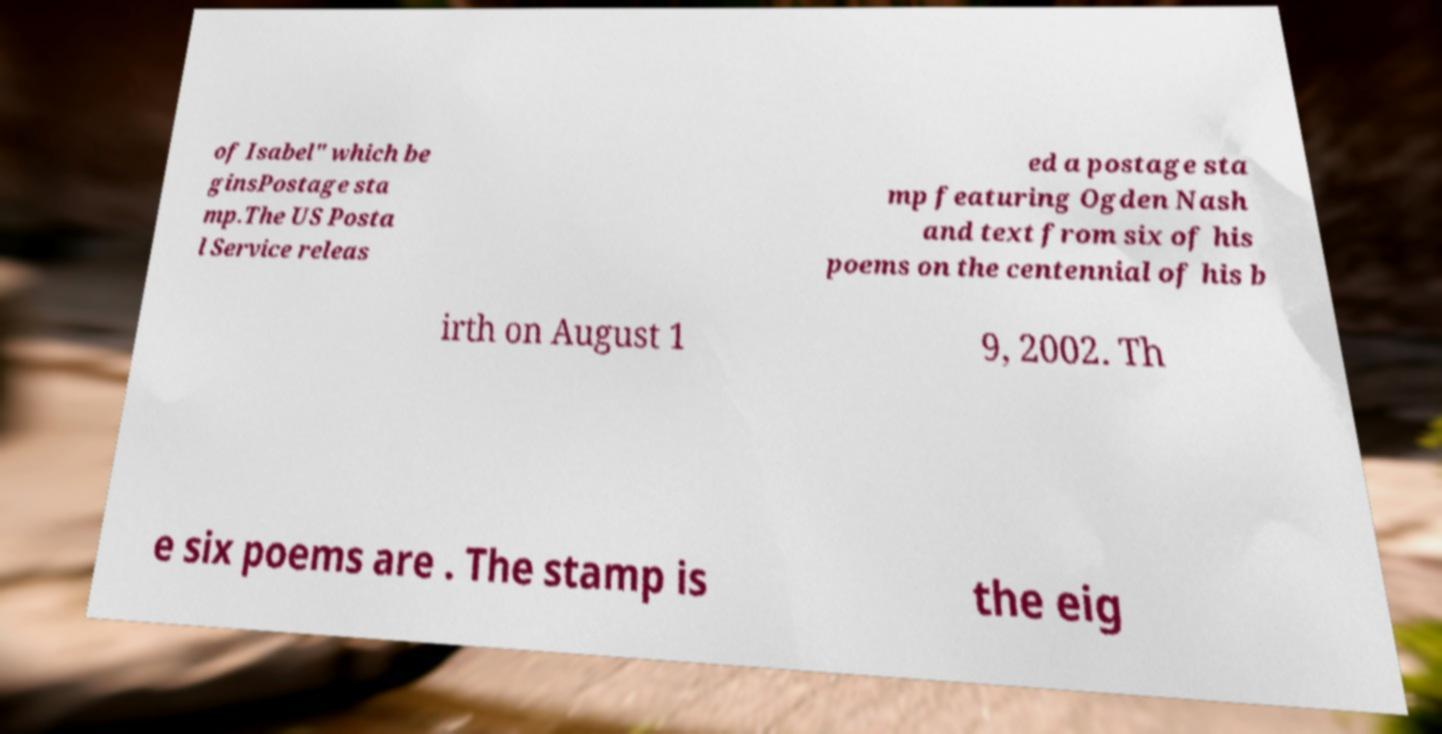Please read and relay the text visible in this image. What does it say? of Isabel" which be ginsPostage sta mp.The US Posta l Service releas ed a postage sta mp featuring Ogden Nash and text from six of his poems on the centennial of his b irth on August 1 9, 2002. Th e six poems are . The stamp is the eig 